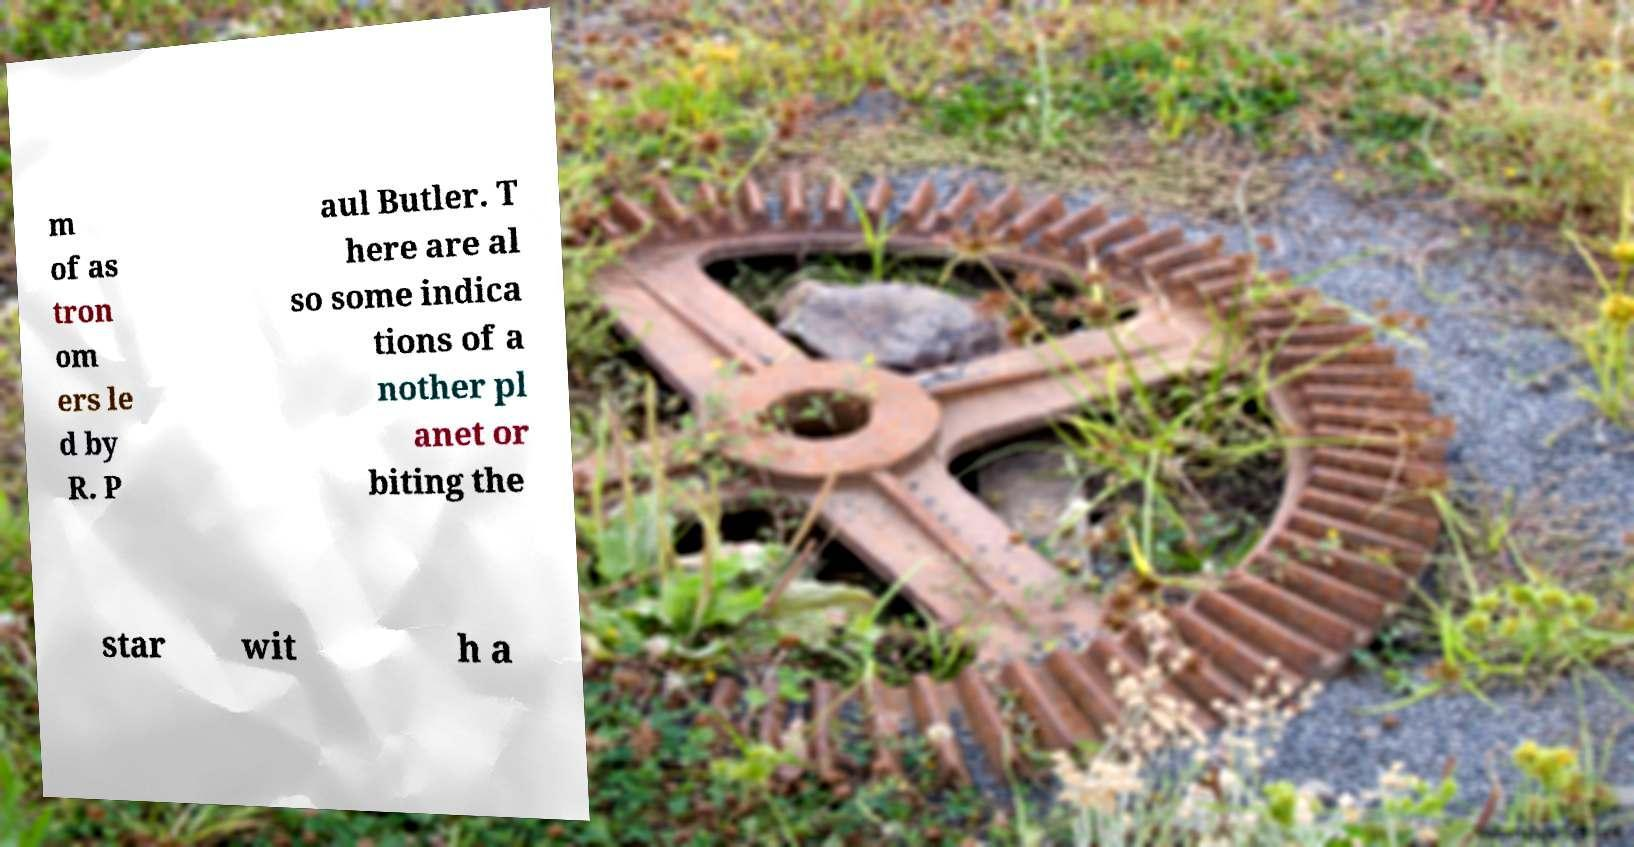There's text embedded in this image that I need extracted. Can you transcribe it verbatim? m of as tron om ers le d by R. P aul Butler. T here are al so some indica tions of a nother pl anet or biting the star wit h a 